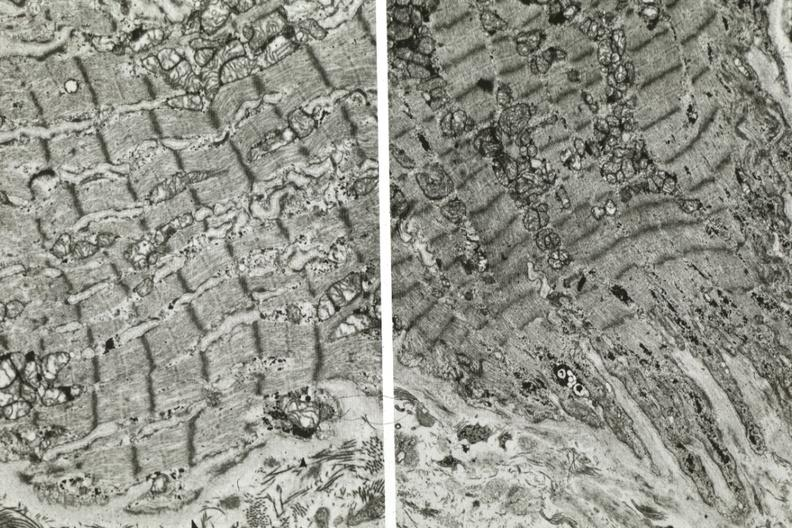s side present?
Answer the question using a single word or phrase. No 